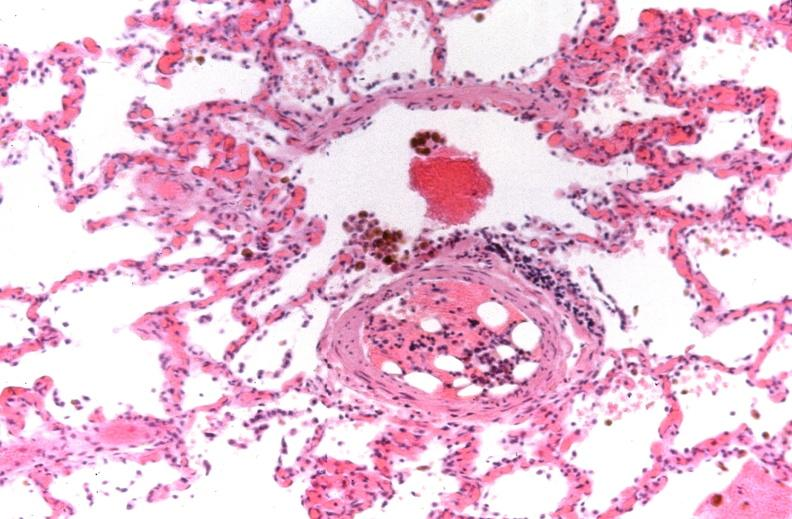what does this image show?
Answer the question using a single word or phrase. Lung 